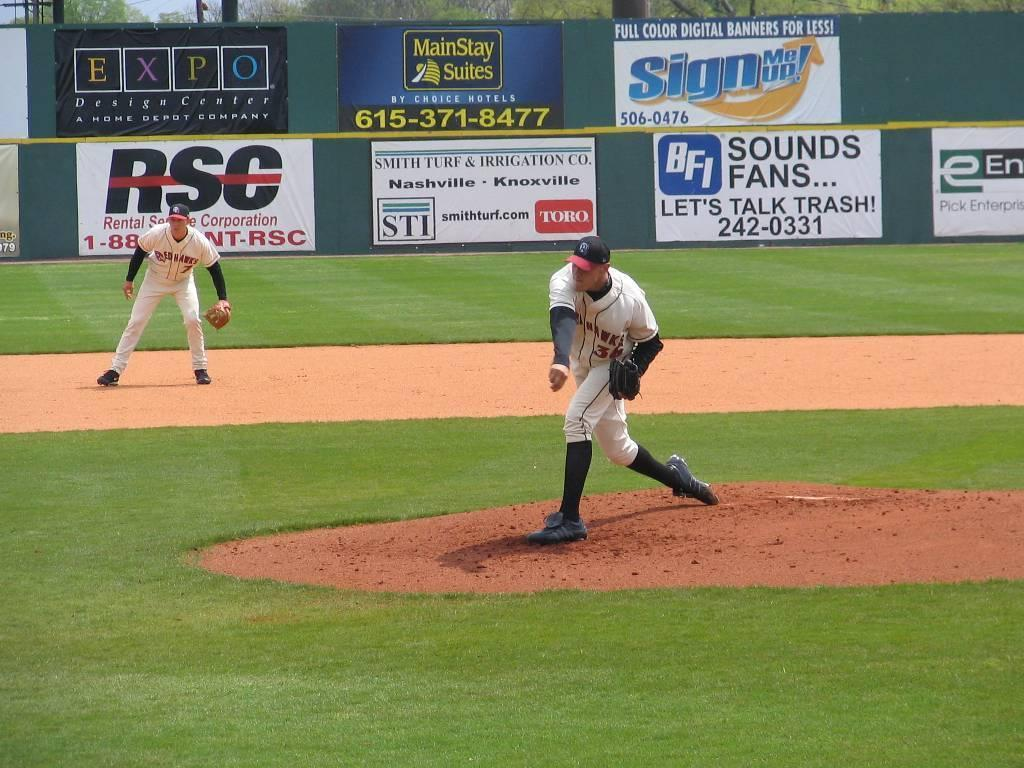<image>
Provide a brief description of the given image. a player with a sounds fan sign way in the background 